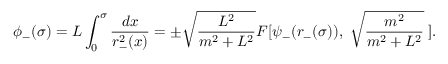Convert formula to latex. <formula><loc_0><loc_0><loc_500><loc_500>\phi _ { - } ( \sigma ) = L \int _ { 0 } ^ { \sigma } \frac { d x } { r _ { - } ^ { 2 } ( x ) } = \pm \sqrt { \frac { L ^ { 2 } } { m ^ { 2 } + L ^ { 2 } } } F [ \psi _ { - } ( r _ { - } ( \sigma ) ) , \, \sqrt { \frac { m ^ { 2 } } { m ^ { 2 } + L ^ { 2 } } } \, ] .</formula> 